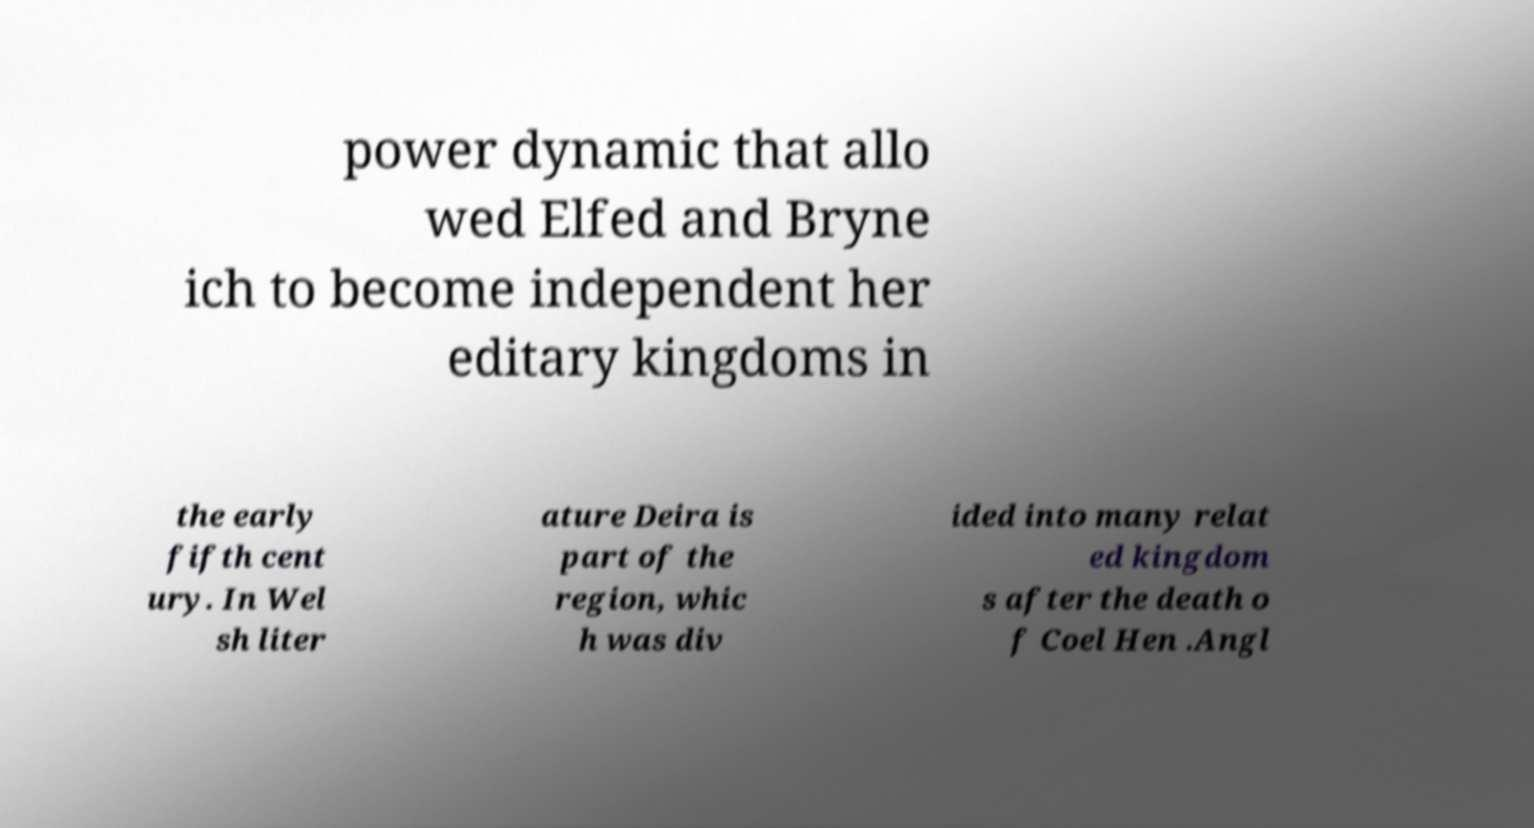Could you assist in decoding the text presented in this image and type it out clearly? power dynamic that allo wed Elfed and Bryne ich to become independent her editary kingdoms in the early fifth cent ury. In Wel sh liter ature Deira is part of the region, whic h was div ided into many relat ed kingdom s after the death o f Coel Hen .Angl 